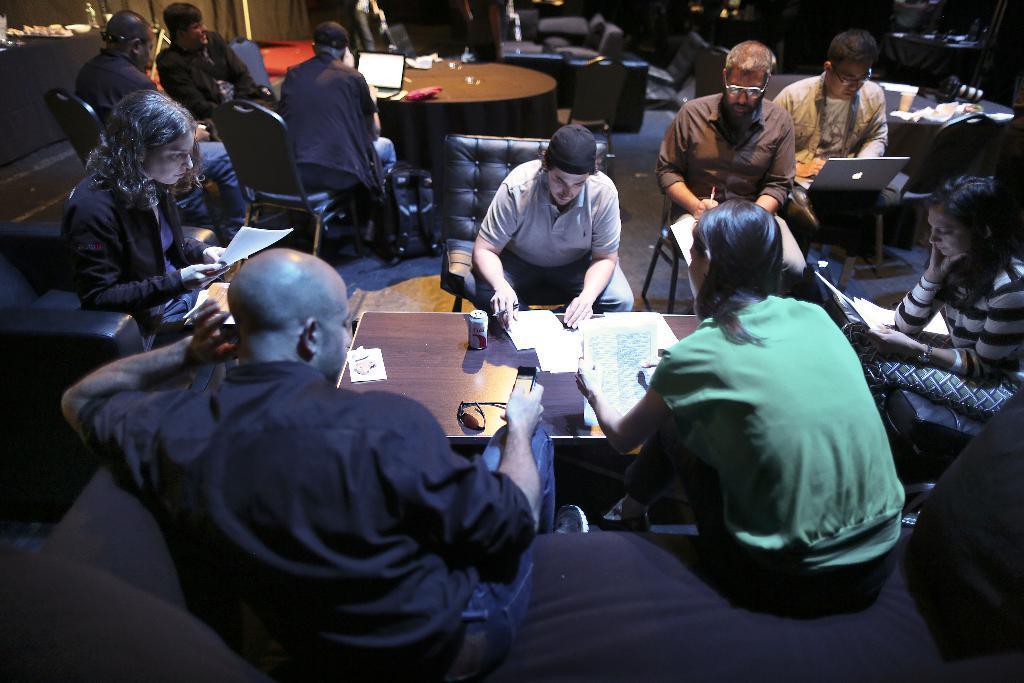Could you give a brief overview of what you see in this image? There is a table which has few books,papers and some other objects on it and there are few people sitting around it and there are few other people in the background. 